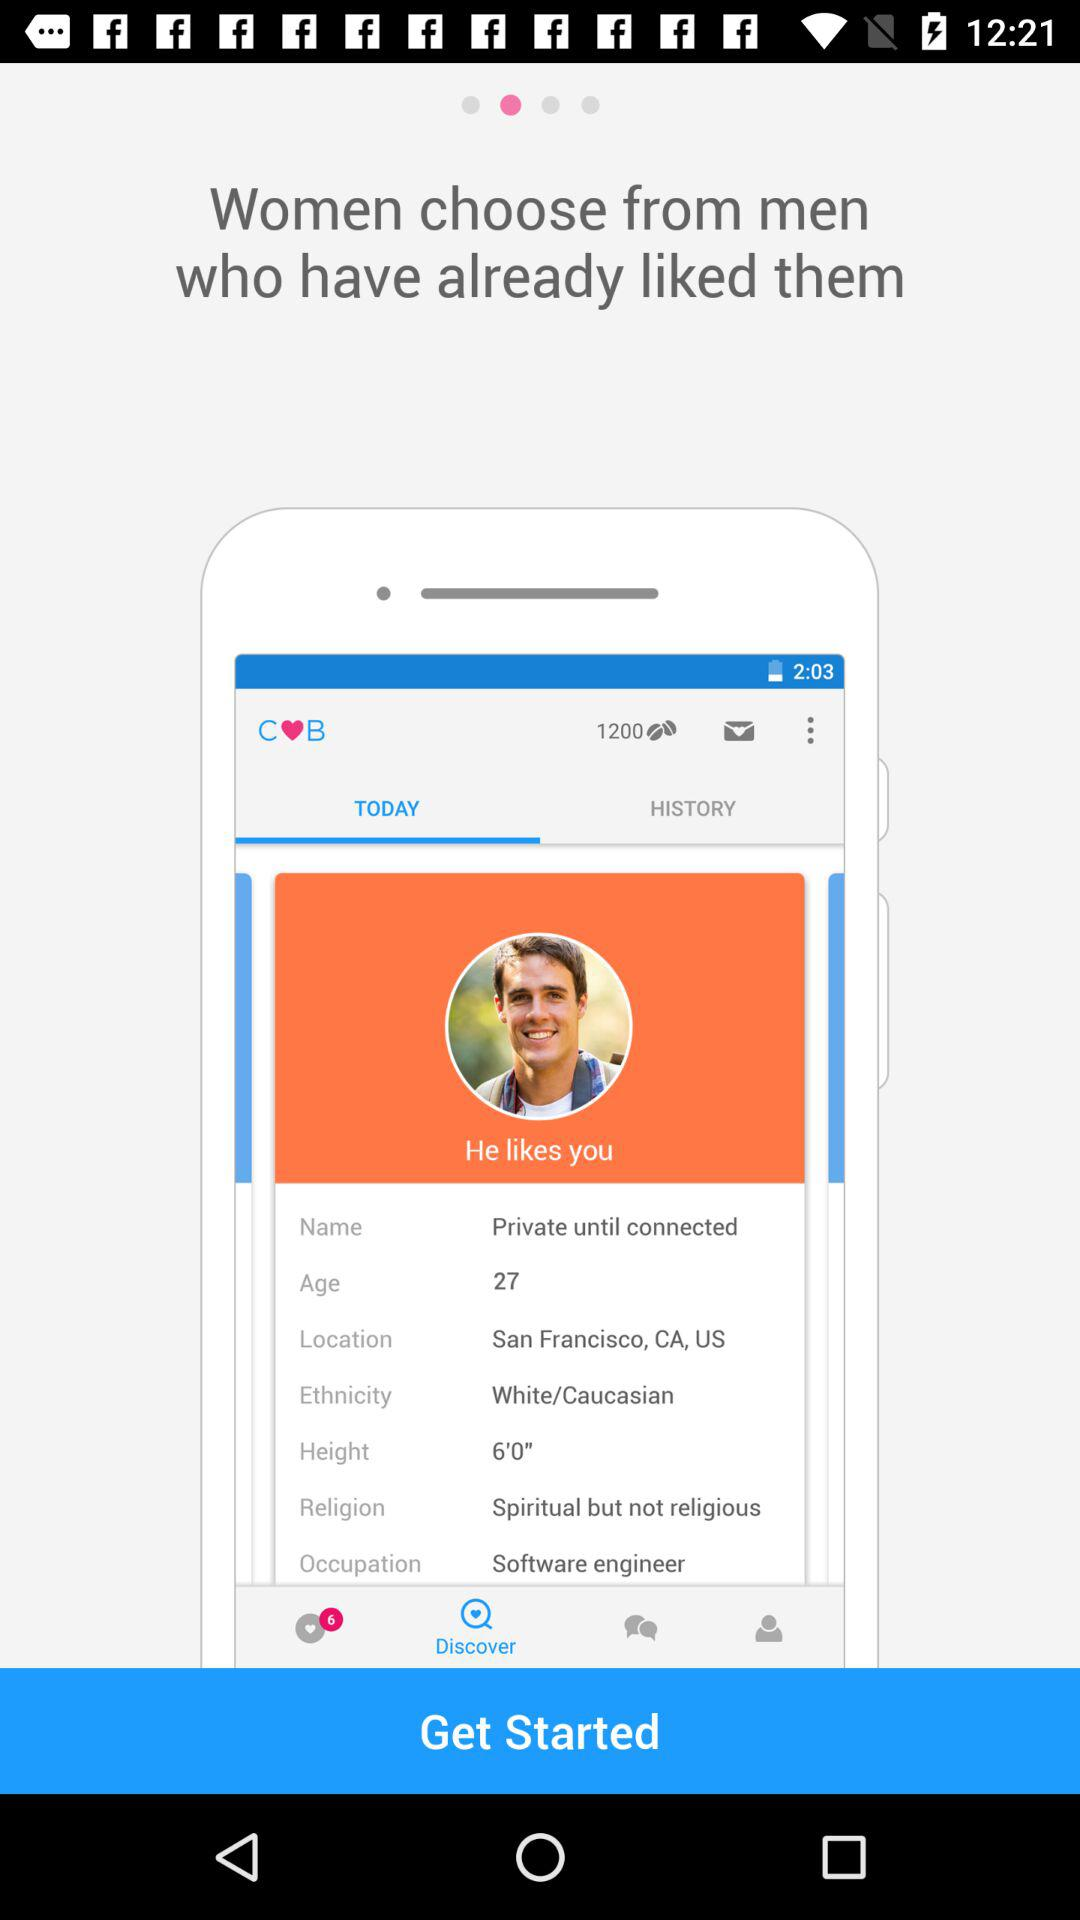How old is the man? The man is 27 years old. 